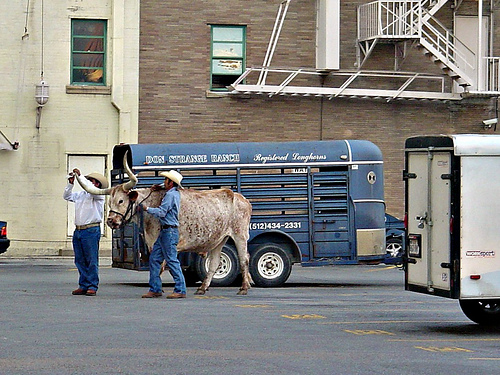<image>
Is there a dull behind the truck? No. The dull is not behind the truck. From this viewpoint, the dull appears to be positioned elsewhere in the scene. Is the animal in front of the trailer? Yes. The animal is positioned in front of the trailer, appearing closer to the camera viewpoint. 